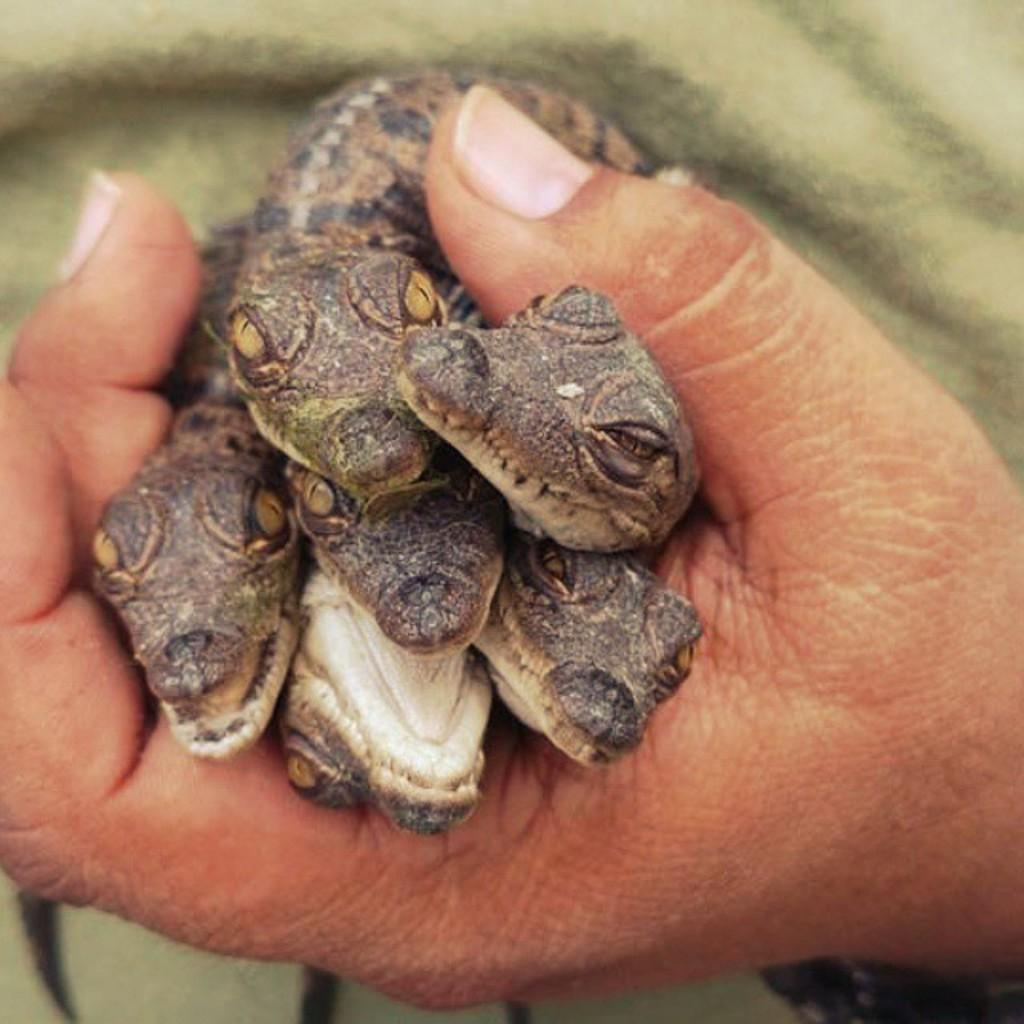What type of animals are present in the image? There are small snakes in the image. Where are the snakes located in the image? The snakes are in the center of the image. What is the context of the snakes in the image? The snakes are in a hand. What type of flowers can be seen growing near the snakes in the image? There are no flowers present in the image; it only features small snakes in a hand. 